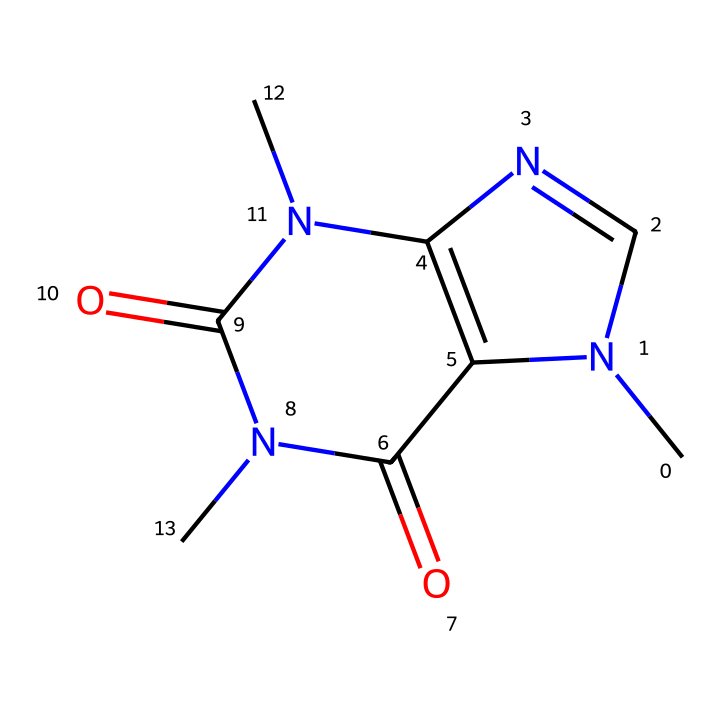What is the molecular formula of caffeine? To determine the molecular formula, we need to count the different types of atoms present in the provided SMILES representation. The breakdown shows there are 8 Carbon (C) atoms, 10 Hydrogen (H) atoms, 4 Nitrogen (N) atoms, and 2 Oxygen (O) atoms. Thus, the molecular formula is C8H10N4O2.
Answer: C8H10N4O2 How many rings are present in the caffeine structure? In the SMILES representation, we observe the numeric indicators (1 and 2), which designate the start and end of rings. Counting these indicators reveals that there are two rings in this structure.
Answer: 2 What functional groups are visible in caffeine? Analyzing the structure, we can identify carbonyls (C=O) and amine groups (N). The presence of these functional groups indicates that caffeine contains both carbonyl and amine functionalities.
Answer: carbonyl, amine What type of solid is caffeine typically categorized as? Caffeine is classified based on its crystalline form and molecular structure as a type of alkaloid, which are naturally occurring compounds that mostly contain basic nitrogen atoms.
Answer: alkaloid What is the boiling point of caffeine in degrees Celsius? The boiling point of a substance can sometimes be found in chemical databases. Caffeine is known to have a boiling point of approximately 178-180 degrees Celsius.
Answer: 178-180 What characteristic of caffeine contributes to its stimulant effect? Caffeine's stimulant effect can be attributed to its ability to act as an antagonist of adenosine receptors due to the nitrogen atoms in the structure which allow it to bind effectively to these receptors.
Answer: adenosine receptors 